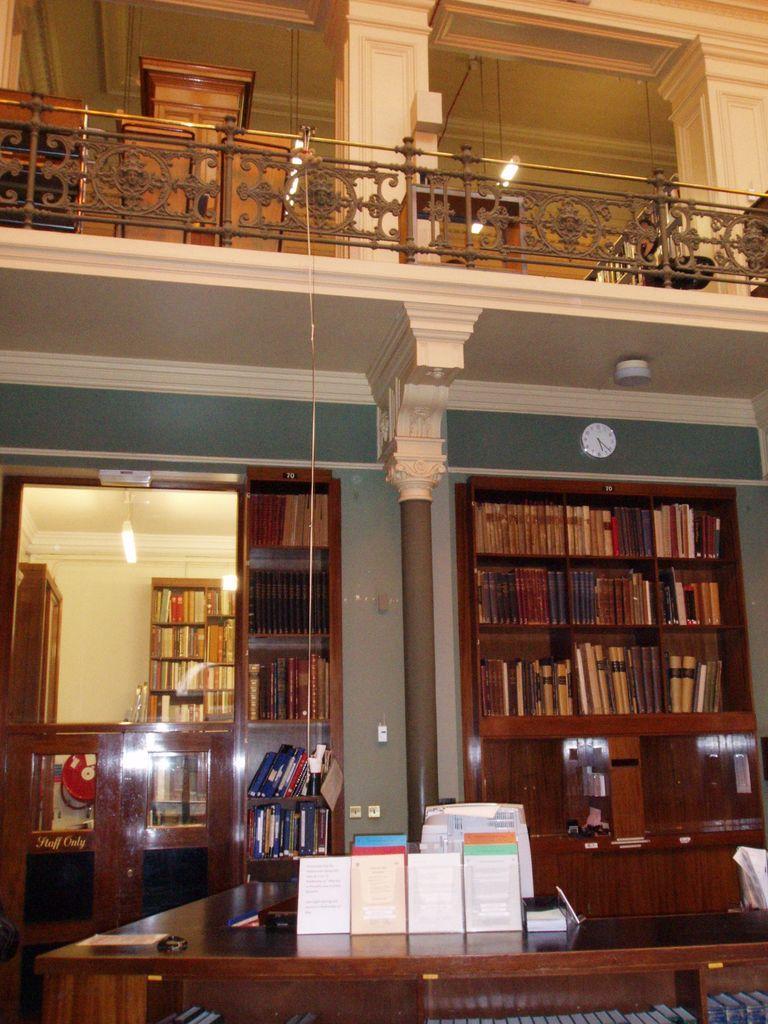Please provide a concise description of this image. In the image we can see on the table there are books and there are bookshelves at the back. 